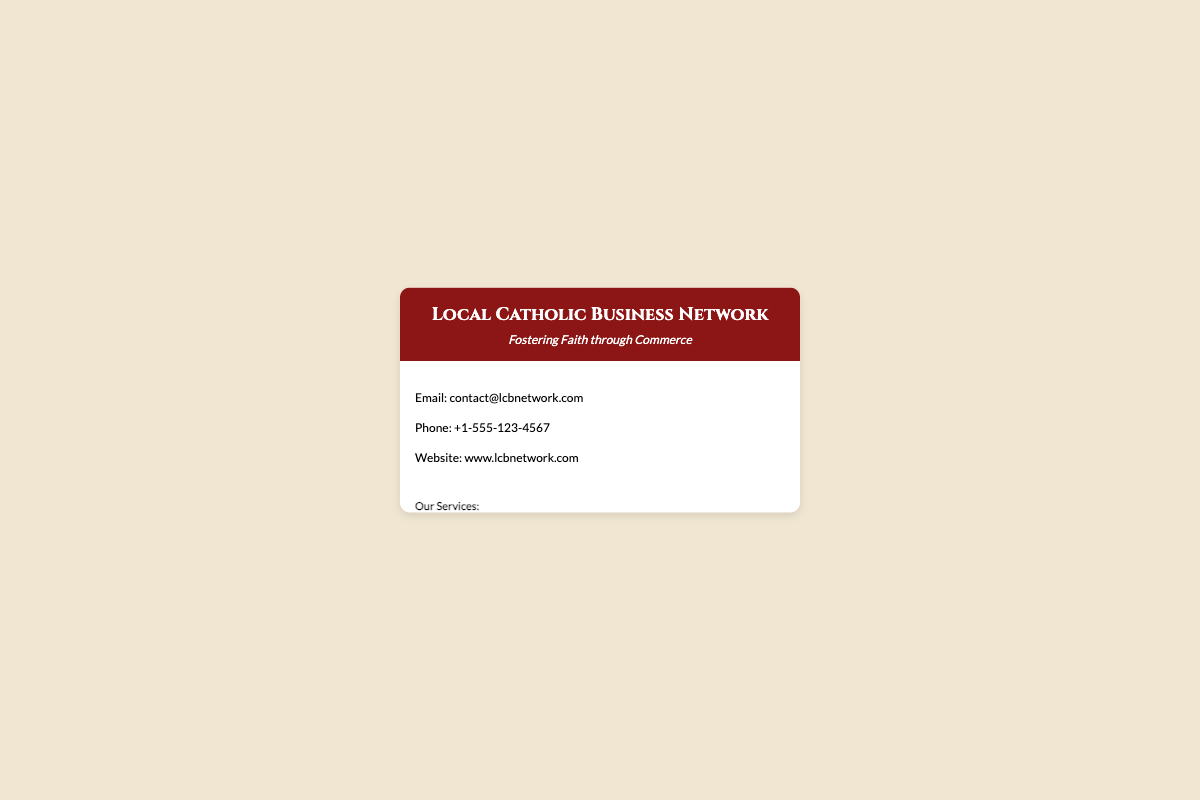What is the business name? The business name is prominently displayed in the header of the document.
Answer: Local Catholic Business Network What is the tagline? The tagline is presented directly under the business name in the header.
Answer: Fostering Faith through Commerce What is the email address? The email address is listed under the contact information section of the document.
Answer: contact@lcbnetwork.com What are the services offered? The services are listed in the content section, each as a separate item.
Answer: The Blessed Bean Café, St. Michael's Bookstore, Holy Family Realty, Guardian Angel Tutoring, St. Joseph's Crafts What is the phone number? The phone number is found in the contact information part of the document.
Answer: +1-555-123-4567 How many services are listed? The total number of services can be counted from the service list in the document.
Answer: 5 Where is the business located? The location is provided in the footer section of the business card.
Answer: 123 Faith Lane, Springfield, State, 12345 What type of card is this? The document is formatted to represent a business card specifically directed towards local businesses.
Answer: Business Card What is the website? The website is found in the contact information section.
Answer: www.lcbnetwork.com 